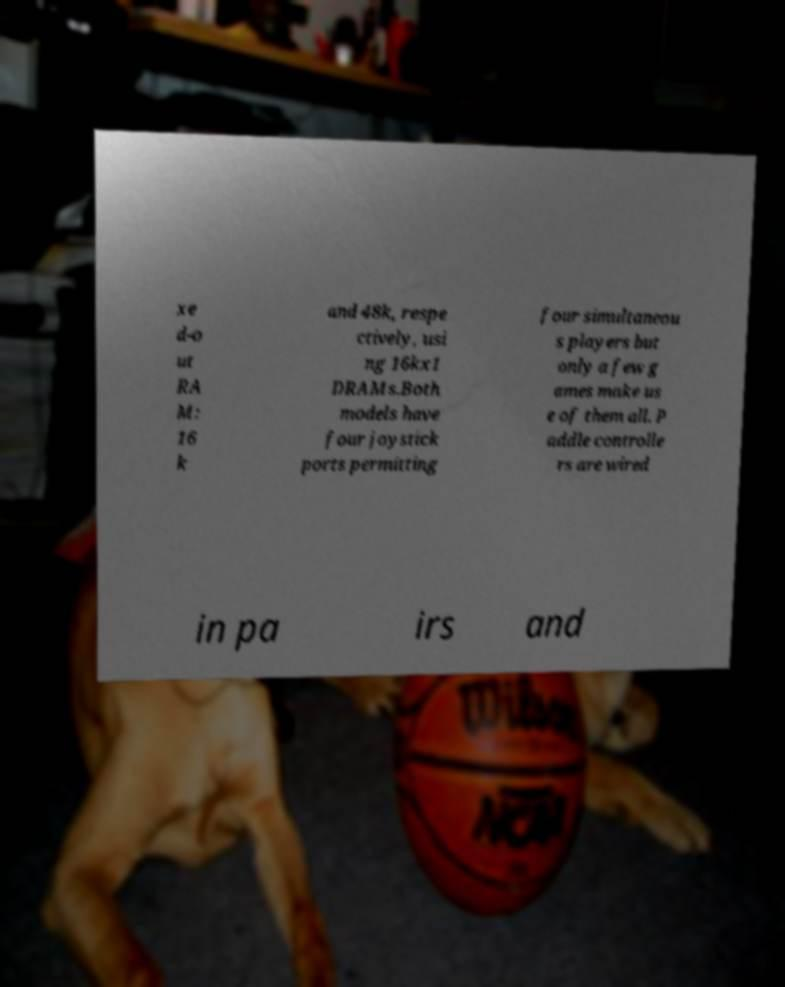What messages or text are displayed in this image? I need them in a readable, typed format. xe d-o ut RA M: 16 k and 48k, respe ctively, usi ng 16kx1 DRAMs.Both models have four joystick ports permitting four simultaneou s players but only a few g ames make us e of them all. P addle controlle rs are wired in pa irs and 